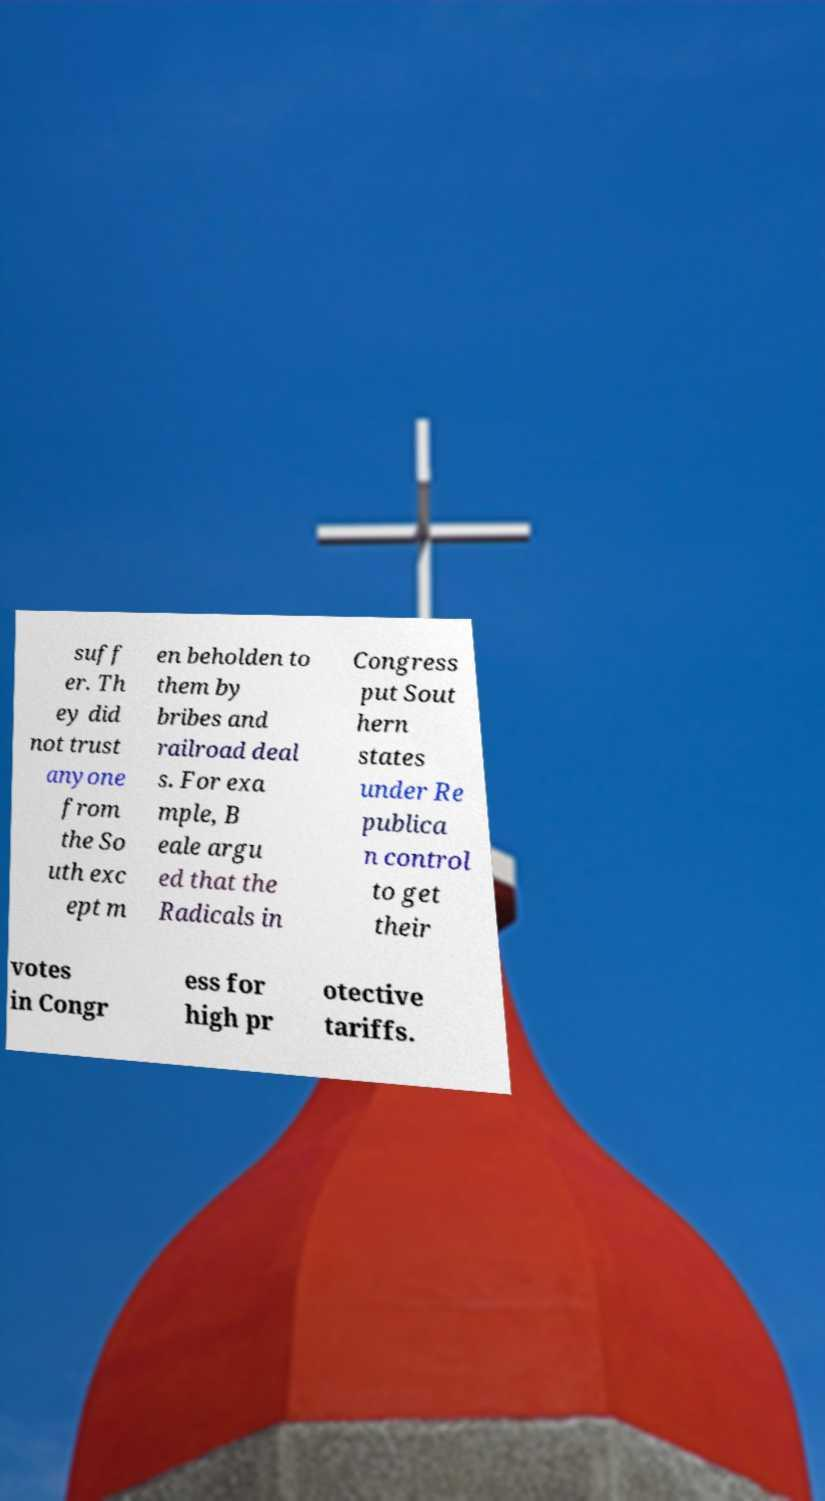Could you assist in decoding the text presented in this image and type it out clearly? suff er. Th ey did not trust anyone from the So uth exc ept m en beholden to them by bribes and railroad deal s. For exa mple, B eale argu ed that the Radicals in Congress put Sout hern states under Re publica n control to get their votes in Congr ess for high pr otective tariffs. 